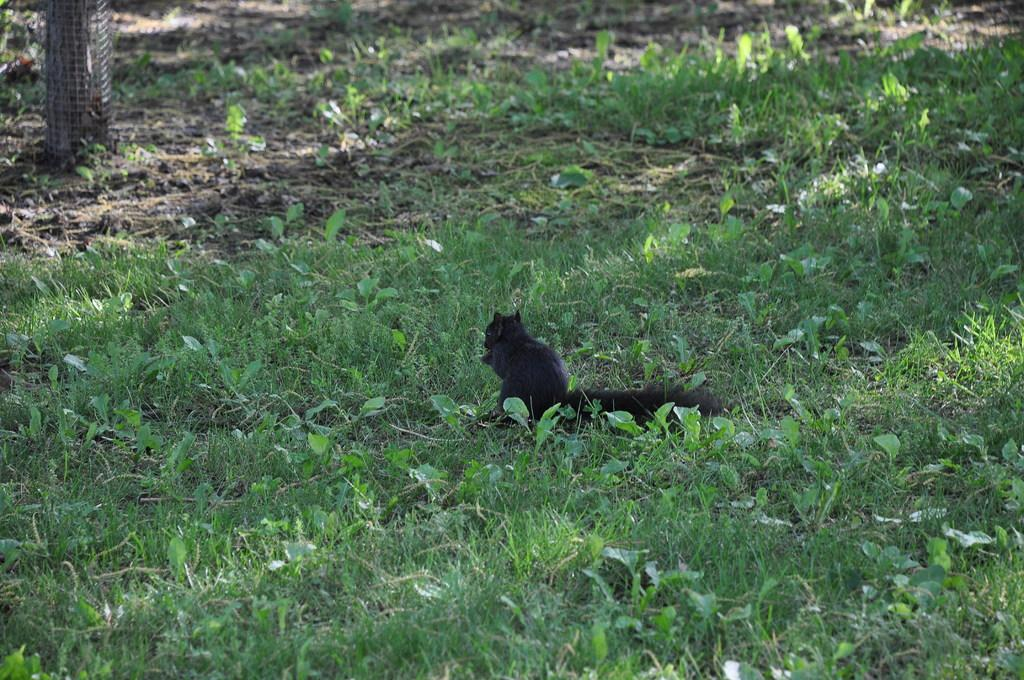What type of animal is sitting on the grass in the image? The facts provided do not specify the type of animal sitting on the grass. Can you describe the object located in the left top corner of the image? The facts provided do not specify the details of the object in the left top corner of the image. What type of seed is the father planting in the image? There is no seed or father present in the image. 